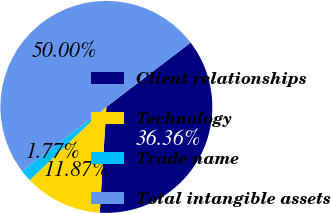Convert chart. <chart><loc_0><loc_0><loc_500><loc_500><pie_chart><fcel>Client relationships<fcel>Technology<fcel>Trade name<fcel>Total intangible assets<nl><fcel>36.36%<fcel>11.87%<fcel>1.77%<fcel>50.0%<nl></chart> 